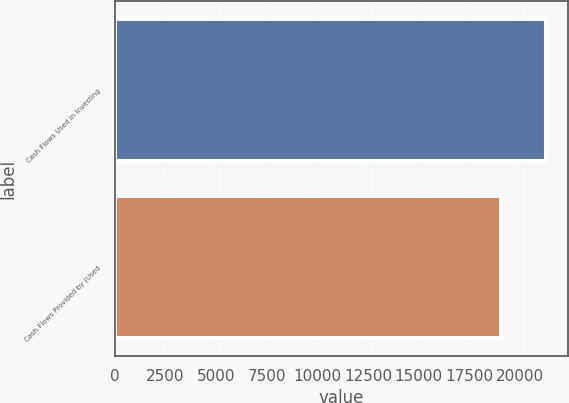<chart> <loc_0><loc_0><loc_500><loc_500><bar_chart><fcel>Cash Flows Used in Investing<fcel>Cash Flows Provided by (Used<nl><fcel>21305<fcel>19046<nl></chart> 